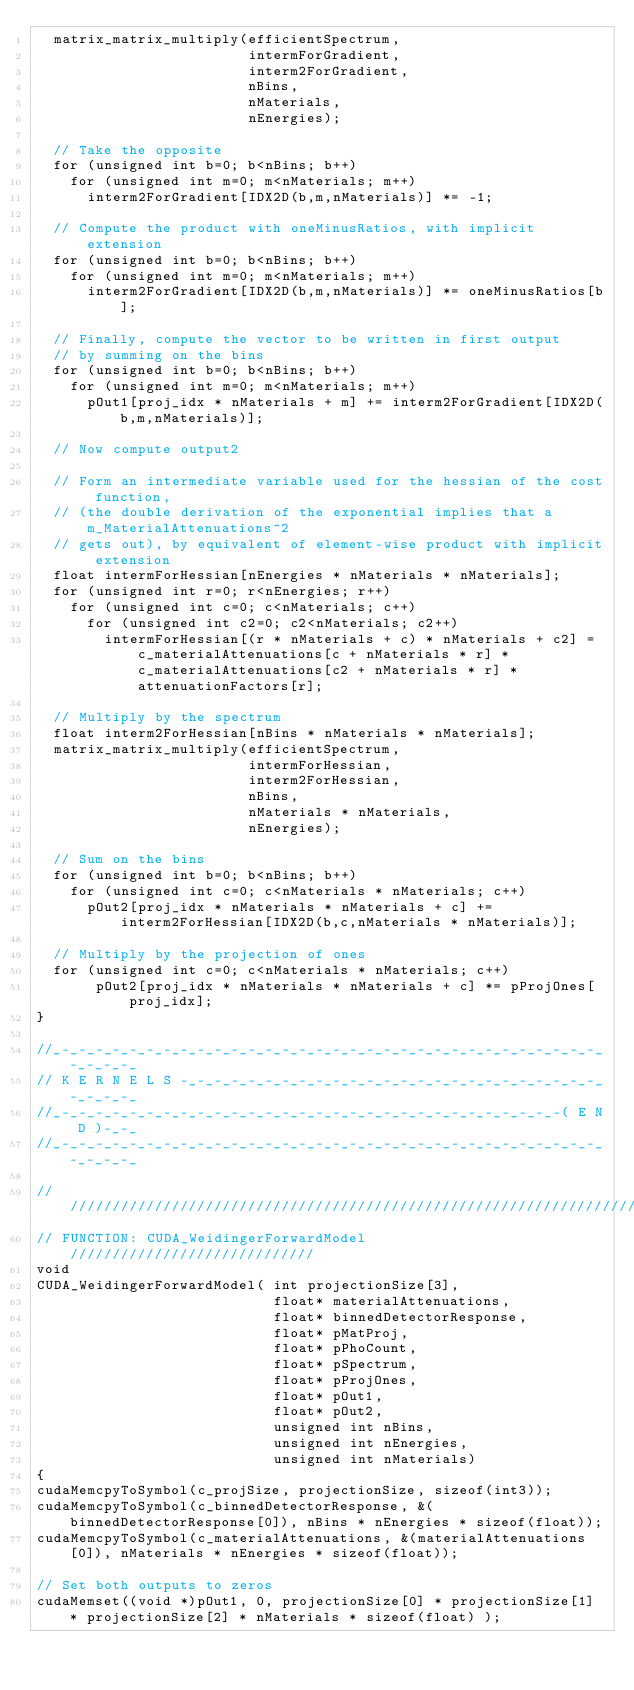Convert code to text. <code><loc_0><loc_0><loc_500><loc_500><_Cuda_>  matrix_matrix_multiply(efficientSpectrum,
                         intermForGradient,
                         interm2ForGradient,
                         nBins,
                         nMaterials,
                         nEnergies);

  // Take the opposite
  for (unsigned int b=0; b<nBins; b++)
    for (unsigned int m=0; m<nMaterials; m++)
      interm2ForGradient[IDX2D(b,m,nMaterials)] *= -1;

  // Compute the product with oneMinusRatios, with implicit extension
  for (unsigned int b=0; b<nBins; b++)
    for (unsigned int m=0; m<nMaterials; m++)
      interm2ForGradient[IDX2D(b,m,nMaterials)] *= oneMinusRatios[b];

  // Finally, compute the vector to be written in first output
  // by summing on the bins
  for (unsigned int b=0; b<nBins; b++)
    for (unsigned int m=0; m<nMaterials; m++)
      pOut1[proj_idx * nMaterials + m] += interm2ForGradient[IDX2D(b,m,nMaterials)];

  // Now compute output2

  // Form an intermediate variable used for the hessian of the cost function,
  // (the double derivation of the exponential implies that a m_MaterialAttenuations^2
  // gets out), by equivalent of element-wise product with implicit extension
  float intermForHessian[nEnergies * nMaterials * nMaterials];
  for (unsigned int r=0; r<nEnergies; r++)
    for (unsigned int c=0; c<nMaterials; c++)
      for (unsigned int c2=0; c2<nMaterials; c2++)
        intermForHessian[(r * nMaterials + c) * nMaterials + c2] = c_materialAttenuations[c + nMaterials * r] * c_materialAttenuations[c2 + nMaterials * r] * attenuationFactors[r];

  // Multiply by the spectrum
  float interm2ForHessian[nBins * nMaterials * nMaterials];
  matrix_matrix_multiply(efficientSpectrum,
                         intermForHessian,
                         interm2ForHessian,
                         nBins,
                         nMaterials * nMaterials,
                         nEnergies);

  // Sum on the bins
  for (unsigned int b=0; b<nBins; b++)
    for (unsigned int c=0; c<nMaterials * nMaterials; c++)
      pOut2[proj_idx * nMaterials * nMaterials + c] += interm2ForHessian[IDX2D(b,c,nMaterials * nMaterials)];

  // Multiply by the projection of ones
  for (unsigned int c=0; c<nMaterials * nMaterials; c++)
       pOut2[proj_idx * nMaterials * nMaterials + c] *= pProjOnes[proj_idx];
}

//_-_-_-_-_-_-_-_-_-_-_-_-_-_-_-_-_-_-_-_-_-_-_-_-_-_-_-_-_-_-_-_-_-_-_-_-_
// K E R N E L S -_-_-_-_-_-_-_-_-_-_-_-_-_-_-_-_-_-_-_-_-_-_-_-_-_-_-_-_-_
//_-_-_-_-_-_-_-_-_-_-_-_-_-_-_-_-_-_-_-_-_-_-_-_-_-_-_-_-_-_-( E N D )-_-_
//_-_-_-_-_-_-_-_-_-_-_-_-_-_-_-_-_-_-_-_-_-_-_-_-_-_-_-_-_-_-_-_-_-_-_-_-_

///////////////////////////////////////////////////////////////////////////
// FUNCTION: CUDA_WeidingerForwardModel /////////////////////////////
void
CUDA_WeidingerForwardModel( int projectionSize[3],
                            float* materialAttenuations,
                            float* binnedDetectorResponse,
                            float* pMatProj,
                            float* pPhoCount,
                            float* pSpectrum,
                            float* pProjOnes,
                            float* pOut1,
                            float* pOut2,
                            unsigned int nBins,
                            unsigned int nEnergies,
                            unsigned int nMaterials)
{
cudaMemcpyToSymbol(c_projSize, projectionSize, sizeof(int3));
cudaMemcpyToSymbol(c_binnedDetectorResponse, &(binnedDetectorResponse[0]), nBins * nEnergies * sizeof(float));
cudaMemcpyToSymbol(c_materialAttenuations, &(materialAttenuations[0]), nMaterials * nEnergies * sizeof(float));

// Set both outputs to zeros
cudaMemset((void *)pOut1, 0, projectionSize[0] * projectionSize[1] * projectionSize[2] * nMaterials * sizeof(float) );</code> 